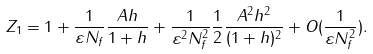<formula> <loc_0><loc_0><loc_500><loc_500>Z _ { 1 } = 1 + \frac { 1 } { \varepsilon N _ { f } } \frac { A h } { 1 + h } + \frac { 1 } { \varepsilon ^ { 2 } N _ { f } ^ { 2 } } \frac { 1 } { 2 } \frac { A ^ { 2 } h ^ { 2 } } { ( 1 + h ) ^ { 2 } } + O ( \frac { 1 } { \varepsilon N _ { f } ^ { 2 } } ) .</formula> 